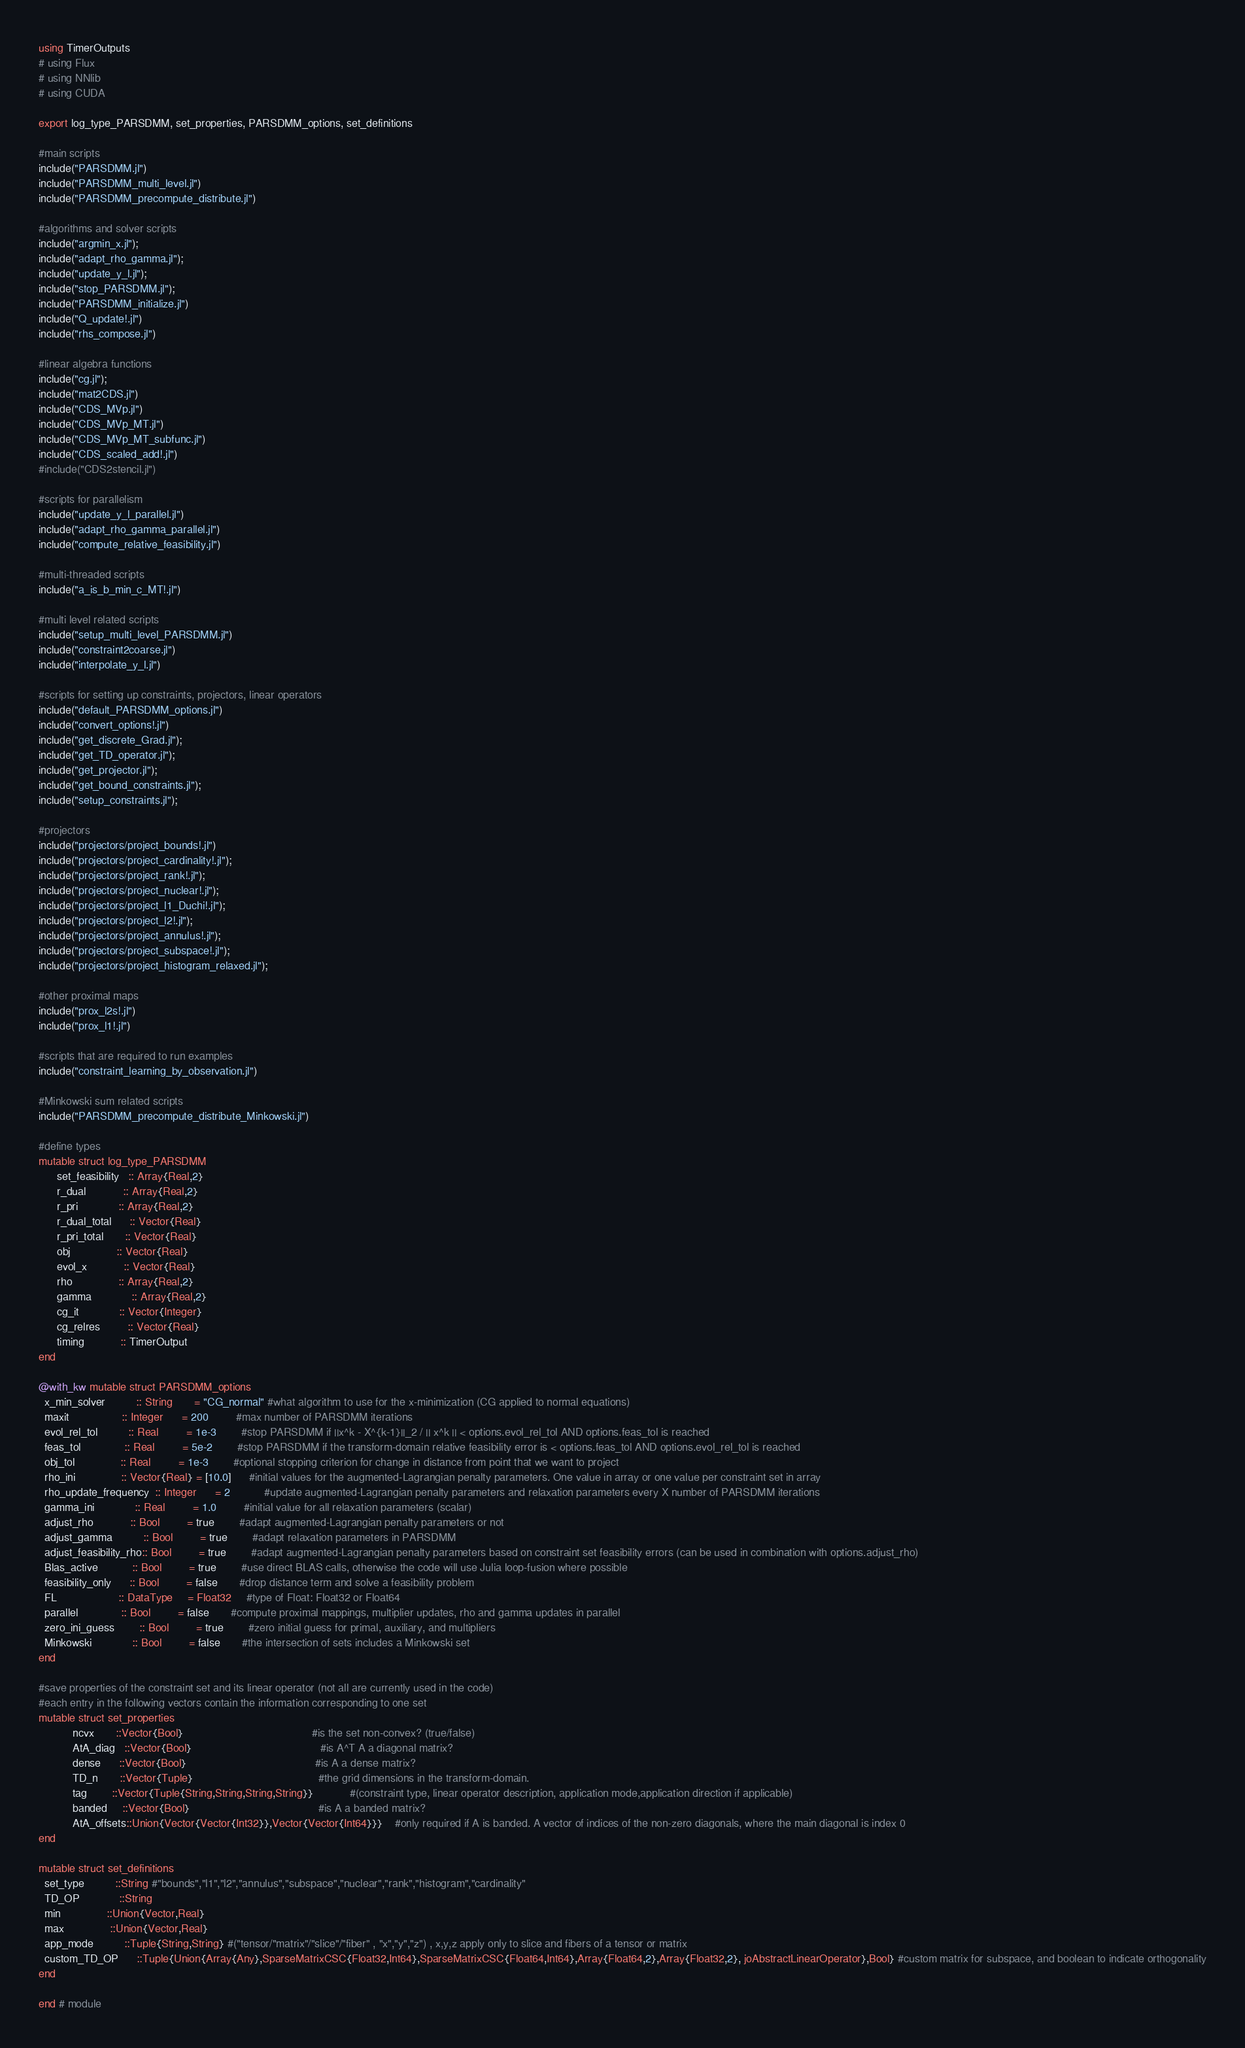Convert code to text. <code><loc_0><loc_0><loc_500><loc_500><_Julia_>using TimerOutputs
# using Flux
# using NNlib
# using CUDA

export log_type_PARSDMM, set_properties, PARSDMM_options, set_definitions

#main scripts
include("PARSDMM.jl")
include("PARSDMM_multi_level.jl")
include("PARSDMM_precompute_distribute.jl")

#algorithms and solver scripts
include("argmin_x.jl");
include("adapt_rho_gamma.jl");
include("update_y_l.jl");
include("stop_PARSDMM.jl");
include("PARSDMM_initialize.jl")
include("Q_update!.jl")
include("rhs_compose.jl")

#linear algebra functions
include("cg.jl");
include("mat2CDS.jl")
include("CDS_MVp.jl")
include("CDS_MVp_MT.jl")
include("CDS_MVp_MT_subfunc.jl")
include("CDS_scaled_add!.jl")
#include("CDS2stencil.jl")

#scripts for parallelism
include("update_y_l_parallel.jl")
include("adapt_rho_gamma_parallel.jl")
include("compute_relative_feasibility.jl")

#multi-threaded scripts
include("a_is_b_min_c_MT!.jl")

#multi level related scripts
include("setup_multi_level_PARSDMM.jl")
include("constraint2coarse.jl")
include("interpolate_y_l.jl")

#scripts for setting up constraints, projectors, linear operators
include("default_PARSDMM_options.jl")
include("convert_options!.jl")
include("get_discrete_Grad.jl");
include("get_TD_operator.jl");
include("get_projector.jl");
include("get_bound_constraints.jl");
include("setup_constraints.jl");

#projectors
include("projectors/project_bounds!.jl")
include("projectors/project_cardinality!.jl");
include("projectors/project_rank!.jl");
include("projectors/project_nuclear!.jl");
include("projectors/project_l1_Duchi!.jl");
include("projectors/project_l2!.jl");
include("projectors/project_annulus!.jl");
include("projectors/project_subspace!.jl");
include("projectors/project_histogram_relaxed.jl");

#other proximal maps
include("prox_l2s!.jl")
include("prox_l1!.jl")

#scripts that are required to run examples
include("constraint_learning_by_observation.jl")

#Minkowski sum related scripts
include("PARSDMM_precompute_distribute_Minkowski.jl")

#define types
mutable struct log_type_PARSDMM
      set_feasibility   :: Array{Real,2}
      r_dual            :: Array{Real,2}
      r_pri             :: Array{Real,2}
      r_dual_total      :: Vector{Real}
      r_pri_total       :: Vector{Real}
      obj               :: Vector{Real}
      evol_x            :: Vector{Real}
      rho               :: Array{Real,2}
      gamma             :: Array{Real,2}
      cg_it             :: Vector{Integer}
      cg_relres         :: Vector{Real}
      timing            :: TimerOutput
end

@with_kw mutable struct PARSDMM_options
  x_min_solver          :: String       = "CG_normal" #what algorithm to use for the x-minimization (CG applied to normal equations)
  maxit                 :: Integer      = 200         #max number of PARSDMM iterations
  evol_rel_tol          :: Real         = 1e-3        #stop PARSDMM if ||x^k - X^{k-1}||_2 / || x^k || < options.evol_rel_tol AND options.feas_tol is reached
  feas_tol              :: Real         = 5e-2        #stop PARSDMM if the transform-domain relative feasibility error is < options.feas_tol AND options.evol_rel_tol is reached
  obj_tol               :: Real         = 1e-3        #optional stopping criterion for change in distance from point that we want to project
  rho_ini               :: Vector{Real} = [10.0]      #initial values for the augmented-Lagrangian penalty parameters. One value in array or one value per constraint set in array
  rho_update_frequency  :: Integer      = 2           #update augmented-Lagrangian penalty parameters and relaxation parameters every X number of PARSDMM iterations
  gamma_ini             :: Real         = 1.0         #initial value for all relaxation parameters (scalar)
  adjust_rho            :: Bool         = true        #adapt augmented-Lagrangian penalty parameters or not
  adjust_gamma          :: Bool         = true        #adapt relaxation parameters in PARSDMM
  adjust_feasibility_rho:: Bool         = true        #adapt augmented-Lagrangian penalty parameters based on constraint set feasibility errors (can be used in combination with options.adjust_rho)
  Blas_active           :: Bool         = true        #use direct BLAS calls, otherwise the code will use Julia loop-fusion where possible
  feasibility_only      :: Bool         = false       #drop distance term and solve a feasibility problem
  FL                    :: DataType     = Float32     #type of Float: Float32 or Float64
  parallel              :: Bool         = false       #compute proximal mappings, multiplier updates, rho and gamma updates in parallel
  zero_ini_guess        :: Bool         = true        #zero initial guess for primal, auxiliary, and multipliers
  Minkowski             :: Bool         = false       #the intersection of sets includes a Minkowski set
end

#save properties of the constraint set and its linear operator (not all are currently used in the code)
#each entry in the following vectors contain the information corresponding to one set
mutable struct set_properties
           ncvx       ::Vector{Bool}                                          #is the set non-convex? (true/false)
           AtA_diag   ::Vector{Bool}                                          #is A^T A a diagonal matrix?
           dense      ::Vector{Bool}                                          #is A a dense matrix?
           TD_n       ::Vector{Tuple}                                         #the grid dimensions in the transform-domain.
           tag        ::Vector{Tuple{String,String,String,String}}            #(constraint type, linear operator description, application mode,application direction if applicable)
           banded     ::Vector{Bool}                                          #is A a banded matrix?
           AtA_offsets::Union{Vector{Vector{Int32}},Vector{Vector{Int64}}}    #only required if A is banded. A vector of indices of the non-zero diagonals, where the main diagonal is index 0
end

mutable struct set_definitions
  set_type          ::String #"bounds","l1","l2","annulus","subspace","nuclear","rank","histogram","cardinality"
  TD_OP             ::String
  min               ::Union{Vector,Real}
  max               ::Union{Vector,Real}
  app_mode          ::Tuple{String,String} #("tensor/"matrix"/"slice"/"fiber" , "x","y","z") , x,y,z apply only to slice and fibers of a tensor or matrix
  custom_TD_OP      ::Tuple{Union{Array{Any},SparseMatrixCSC{Float32,Int64},SparseMatrixCSC{Float64,Int64},Array{Float64,2},Array{Float32,2}, joAbstractLinearOperator},Bool} #custom matrix for subspace, and boolean to indicate orthogonality
end

end # module
</code> 